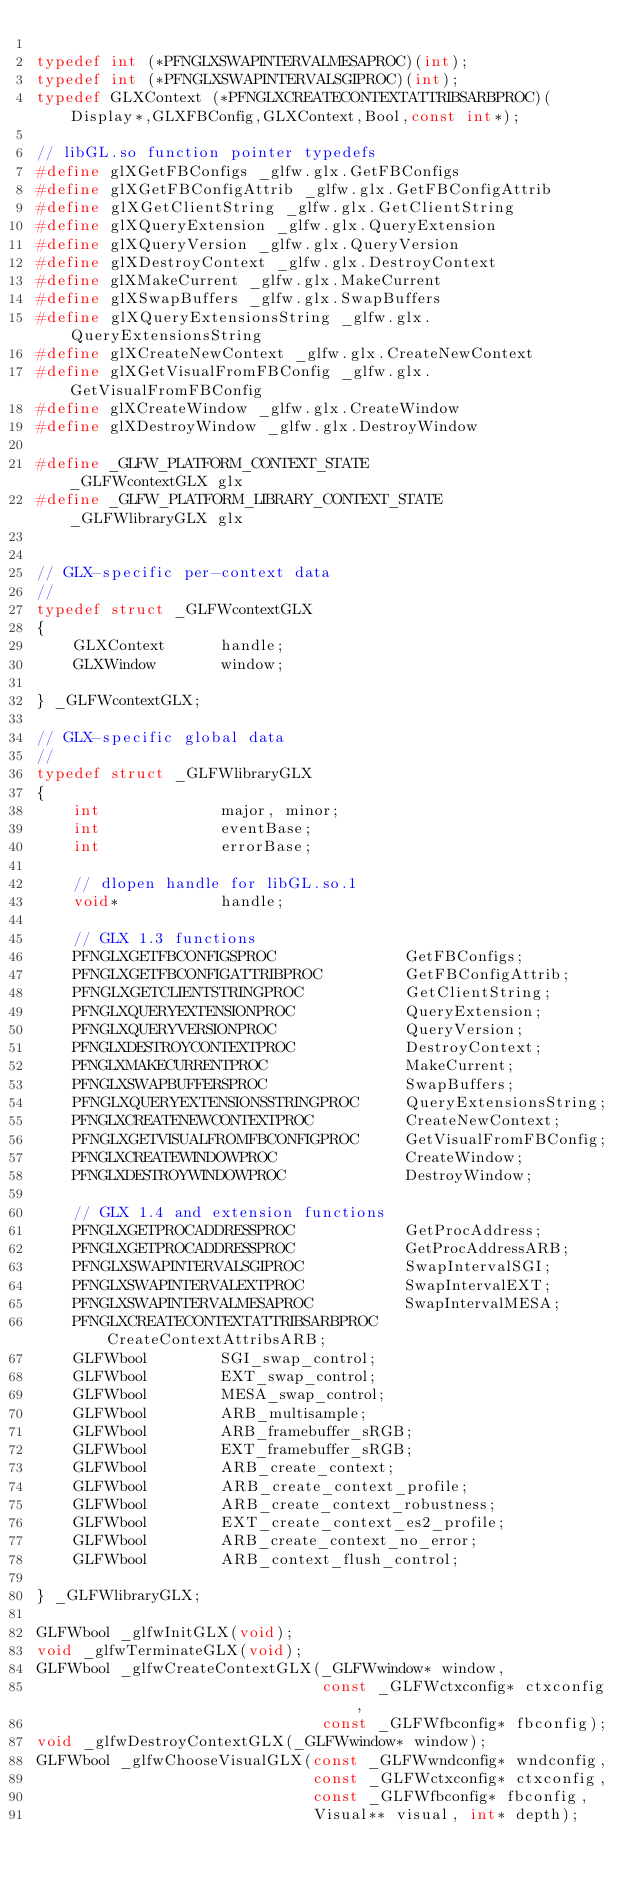<code> <loc_0><loc_0><loc_500><loc_500><_C_>
typedef int (*PFNGLXSWAPINTERVALMESAPROC)(int);
typedef int (*PFNGLXSWAPINTERVALSGIPROC)(int);
typedef GLXContext (*PFNGLXCREATECONTEXTATTRIBSARBPROC)(Display*,GLXFBConfig,GLXContext,Bool,const int*);

// libGL.so function pointer typedefs
#define glXGetFBConfigs _glfw.glx.GetFBConfigs
#define glXGetFBConfigAttrib _glfw.glx.GetFBConfigAttrib
#define glXGetClientString _glfw.glx.GetClientString
#define glXQueryExtension _glfw.glx.QueryExtension
#define glXQueryVersion _glfw.glx.QueryVersion
#define glXDestroyContext _glfw.glx.DestroyContext
#define glXMakeCurrent _glfw.glx.MakeCurrent
#define glXSwapBuffers _glfw.glx.SwapBuffers
#define glXQueryExtensionsString _glfw.glx.QueryExtensionsString
#define glXCreateNewContext _glfw.glx.CreateNewContext
#define glXGetVisualFromFBConfig _glfw.glx.GetVisualFromFBConfig
#define glXCreateWindow _glfw.glx.CreateWindow
#define glXDestroyWindow _glfw.glx.DestroyWindow

#define _GLFW_PLATFORM_CONTEXT_STATE            _GLFWcontextGLX glx
#define _GLFW_PLATFORM_LIBRARY_CONTEXT_STATE    _GLFWlibraryGLX glx


// GLX-specific per-context data
//
typedef struct _GLFWcontextGLX
{
    GLXContext      handle;
    GLXWindow       window;

} _GLFWcontextGLX;

// GLX-specific global data
//
typedef struct _GLFWlibraryGLX
{
    int             major, minor;
    int             eventBase;
    int             errorBase;

    // dlopen handle for libGL.so.1
    void*           handle;

    // GLX 1.3 functions
    PFNGLXGETFBCONFIGSPROC              GetFBConfigs;
    PFNGLXGETFBCONFIGATTRIBPROC         GetFBConfigAttrib;
    PFNGLXGETCLIENTSTRINGPROC           GetClientString;
    PFNGLXQUERYEXTENSIONPROC            QueryExtension;
    PFNGLXQUERYVERSIONPROC              QueryVersion;
    PFNGLXDESTROYCONTEXTPROC            DestroyContext;
    PFNGLXMAKECURRENTPROC               MakeCurrent;
    PFNGLXSWAPBUFFERSPROC               SwapBuffers;
    PFNGLXQUERYEXTENSIONSSTRINGPROC     QueryExtensionsString;
    PFNGLXCREATENEWCONTEXTPROC          CreateNewContext;
    PFNGLXGETVISUALFROMFBCONFIGPROC     GetVisualFromFBConfig;
    PFNGLXCREATEWINDOWPROC              CreateWindow;
    PFNGLXDESTROYWINDOWPROC             DestroyWindow;

    // GLX 1.4 and extension functions
    PFNGLXGETPROCADDRESSPROC            GetProcAddress;
    PFNGLXGETPROCADDRESSPROC            GetProcAddressARB;
    PFNGLXSWAPINTERVALSGIPROC           SwapIntervalSGI;
    PFNGLXSWAPINTERVALEXTPROC           SwapIntervalEXT;
    PFNGLXSWAPINTERVALMESAPROC          SwapIntervalMESA;
    PFNGLXCREATECONTEXTATTRIBSARBPROC   CreateContextAttribsARB;
    GLFWbool        SGI_swap_control;
    GLFWbool        EXT_swap_control;
    GLFWbool        MESA_swap_control;
    GLFWbool        ARB_multisample;
    GLFWbool        ARB_framebuffer_sRGB;
    GLFWbool        EXT_framebuffer_sRGB;
    GLFWbool        ARB_create_context;
    GLFWbool        ARB_create_context_profile;
    GLFWbool        ARB_create_context_robustness;
    GLFWbool        EXT_create_context_es2_profile;
    GLFWbool        ARB_create_context_no_error;
    GLFWbool        ARB_context_flush_control;

} _GLFWlibraryGLX;

GLFWbool _glfwInitGLX(void);
void _glfwTerminateGLX(void);
GLFWbool _glfwCreateContextGLX(_GLFWwindow* window,
                               const _GLFWctxconfig* ctxconfig,
                               const _GLFWfbconfig* fbconfig);
void _glfwDestroyContextGLX(_GLFWwindow* window);
GLFWbool _glfwChooseVisualGLX(const _GLFWwndconfig* wndconfig,
                              const _GLFWctxconfig* ctxconfig,
                              const _GLFWfbconfig* fbconfig,
                              Visual** visual, int* depth);

</code> 